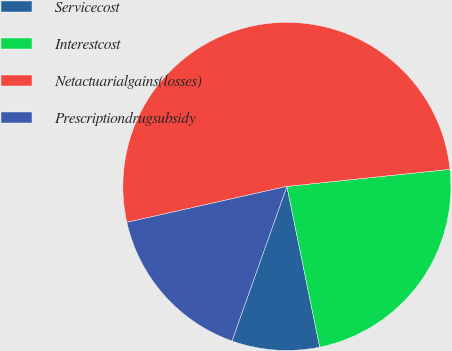<chart> <loc_0><loc_0><loc_500><loc_500><pie_chart><fcel>Servicecost<fcel>Interestcost<fcel>Netactuarialgains(losses)<fcel>Prescriptiondrugsubsidy<nl><fcel>8.64%<fcel>23.46%<fcel>51.85%<fcel>16.05%<nl></chart> 